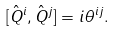Convert formula to latex. <formula><loc_0><loc_0><loc_500><loc_500>[ \hat { Q } ^ { i } , \hat { Q } ^ { j } ] = i \theta ^ { i j } .</formula> 